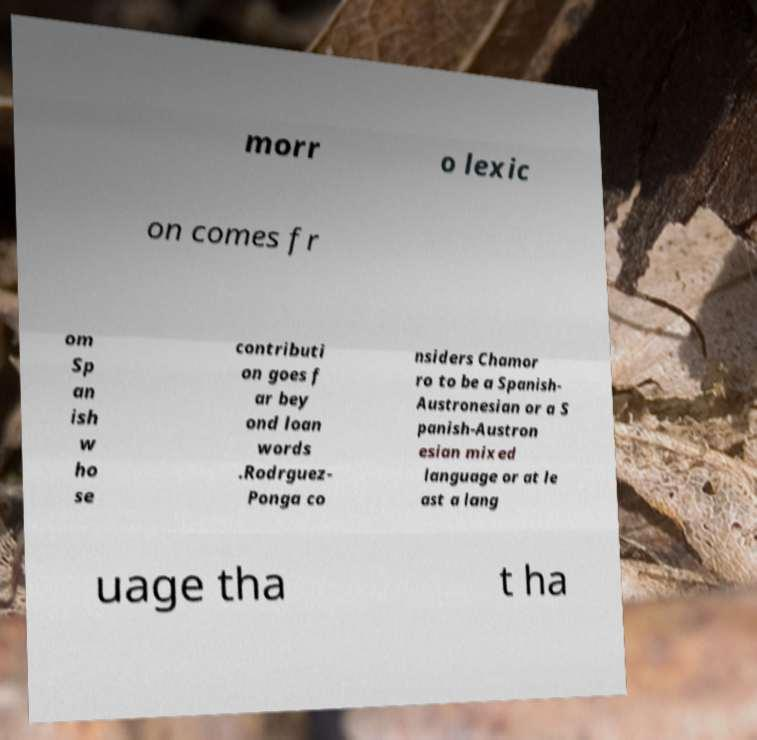Could you assist in decoding the text presented in this image and type it out clearly? morr o lexic on comes fr om Sp an ish w ho se contributi on goes f ar bey ond loan words .Rodrguez- Ponga co nsiders Chamor ro to be a Spanish- Austronesian or a S panish-Austron esian mixed language or at le ast a lang uage tha t ha 